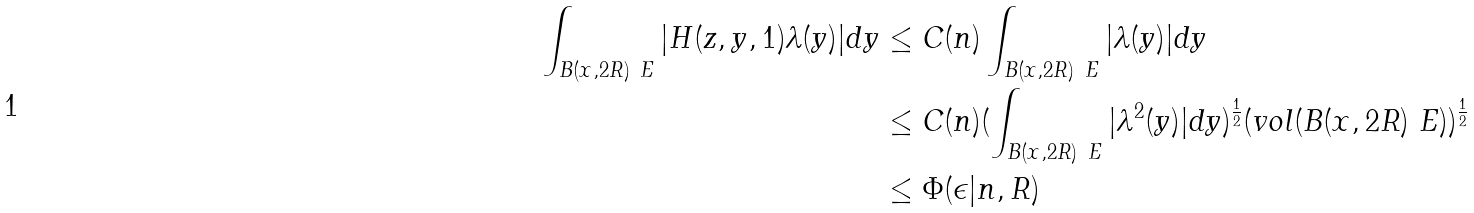<formula> <loc_0><loc_0><loc_500><loc_500>\int _ { B ( x , 2 R ) \ E } | H ( z , y , 1 ) \lambda ( y ) | d y & \leq C ( n ) \int _ { B ( x , 2 R ) \ E } | \lambda ( y ) | d y \\ & \leq C ( n ) ( \int _ { B ( x , 2 R ) \ E } | \lambda ^ { 2 } ( y ) | d y ) ^ { \frac { 1 } { 2 } } ( v o l ( B ( x , 2 R ) \ E ) ) ^ { \frac { 1 } { 2 } } \\ & \leq \Phi ( \epsilon | n , R )</formula> 